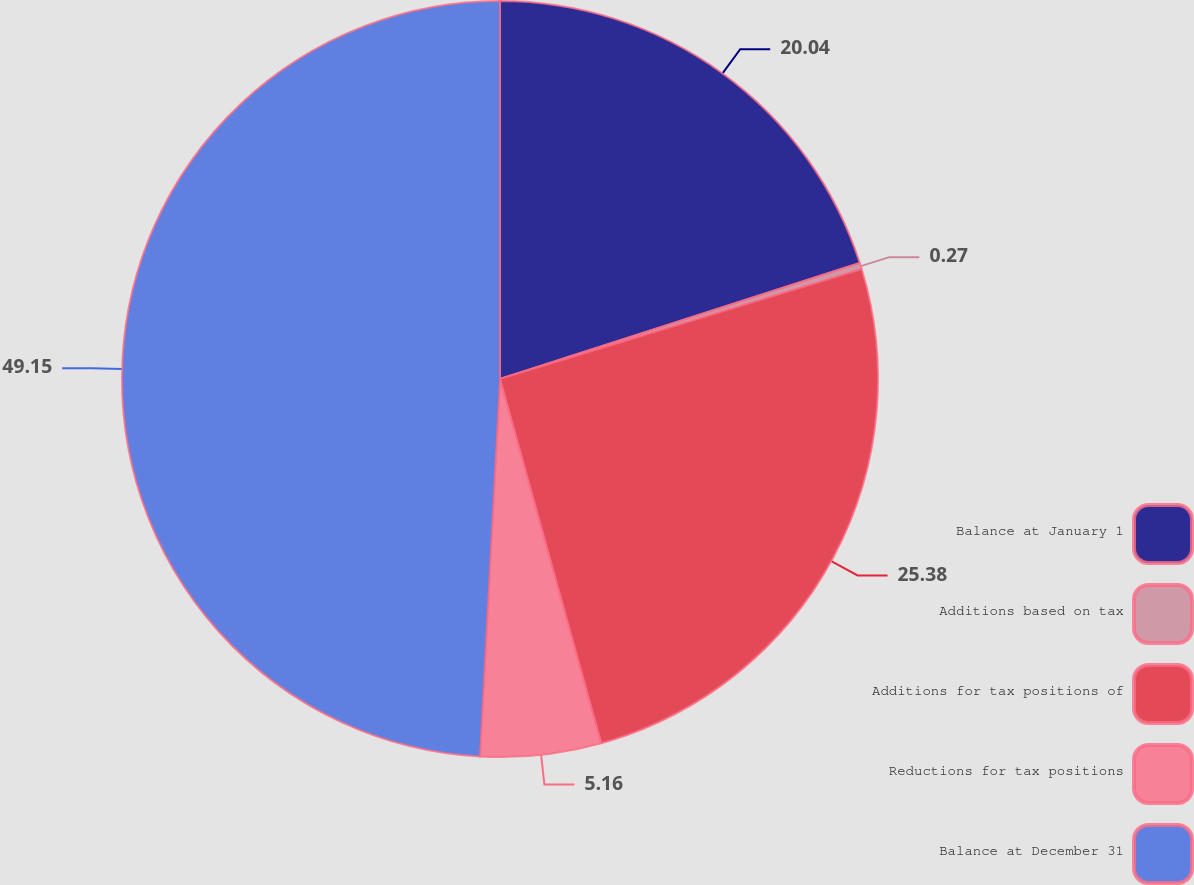<chart> <loc_0><loc_0><loc_500><loc_500><pie_chart><fcel>Balance at January 1<fcel>Additions based on tax<fcel>Additions for tax positions of<fcel>Reductions for tax positions<fcel>Balance at December 31<nl><fcel>20.04%<fcel>0.27%<fcel>25.38%<fcel>5.16%<fcel>49.16%<nl></chart> 